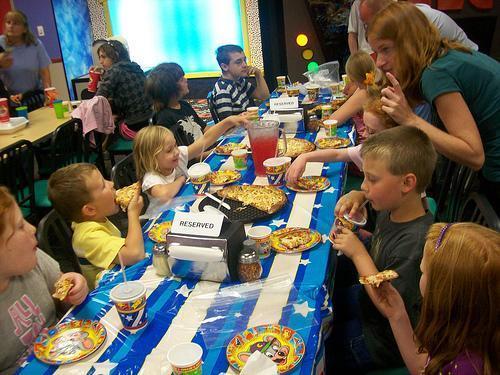How many people are in the picture?
Give a very brief answer. 13. 